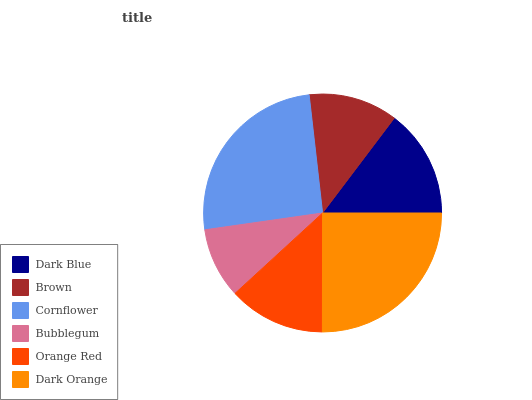Is Bubblegum the minimum?
Answer yes or no. Yes. Is Cornflower the maximum?
Answer yes or no. Yes. Is Brown the minimum?
Answer yes or no. No. Is Brown the maximum?
Answer yes or no. No. Is Dark Blue greater than Brown?
Answer yes or no. Yes. Is Brown less than Dark Blue?
Answer yes or no. Yes. Is Brown greater than Dark Blue?
Answer yes or no. No. Is Dark Blue less than Brown?
Answer yes or no. No. Is Dark Blue the high median?
Answer yes or no. Yes. Is Orange Red the low median?
Answer yes or no. Yes. Is Dark Orange the high median?
Answer yes or no. No. Is Dark Blue the low median?
Answer yes or no. No. 